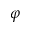<formula> <loc_0><loc_0><loc_500><loc_500>\varphi</formula> 